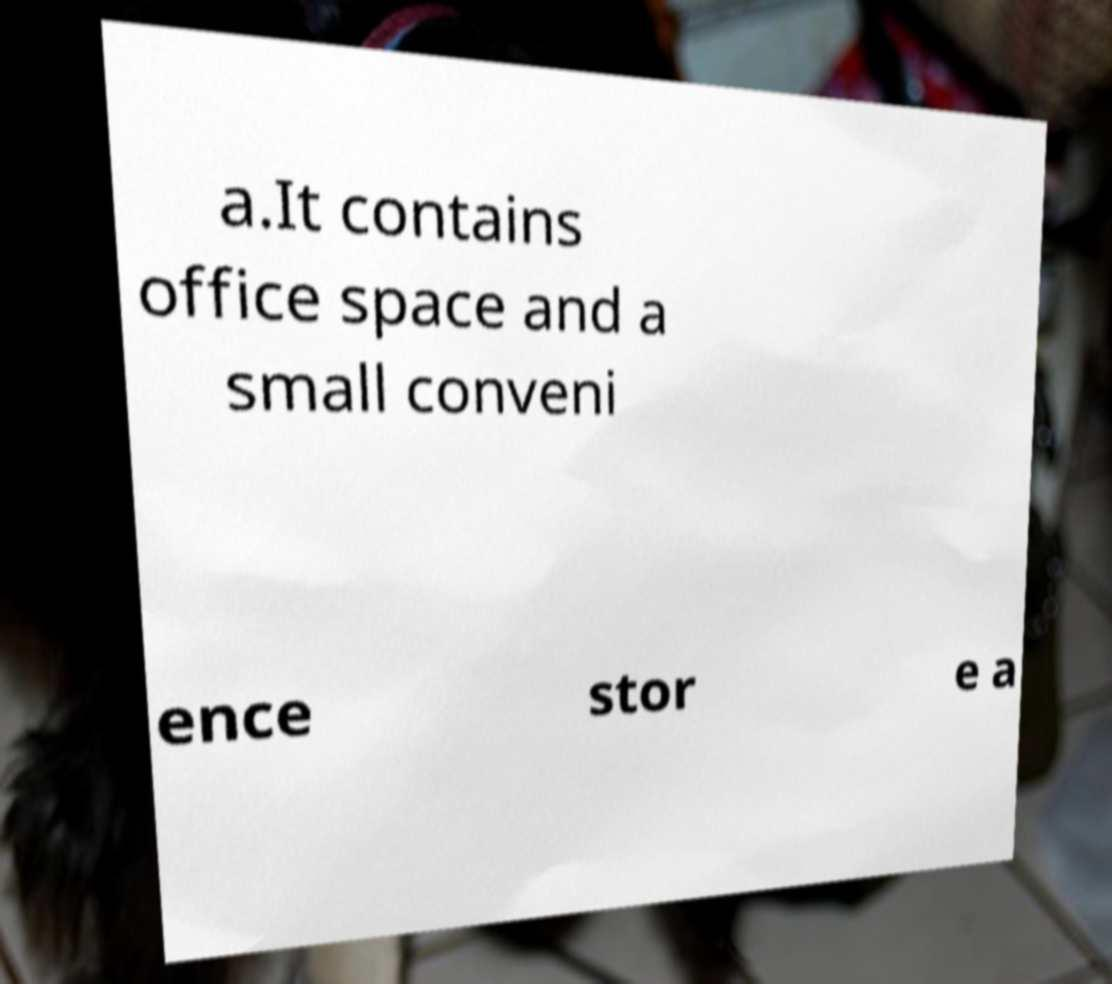Could you extract and type out the text from this image? a.It contains office space and a small conveni ence stor e a 